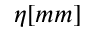<formula> <loc_0><loc_0><loc_500><loc_500>\eta [ m m ]</formula> 